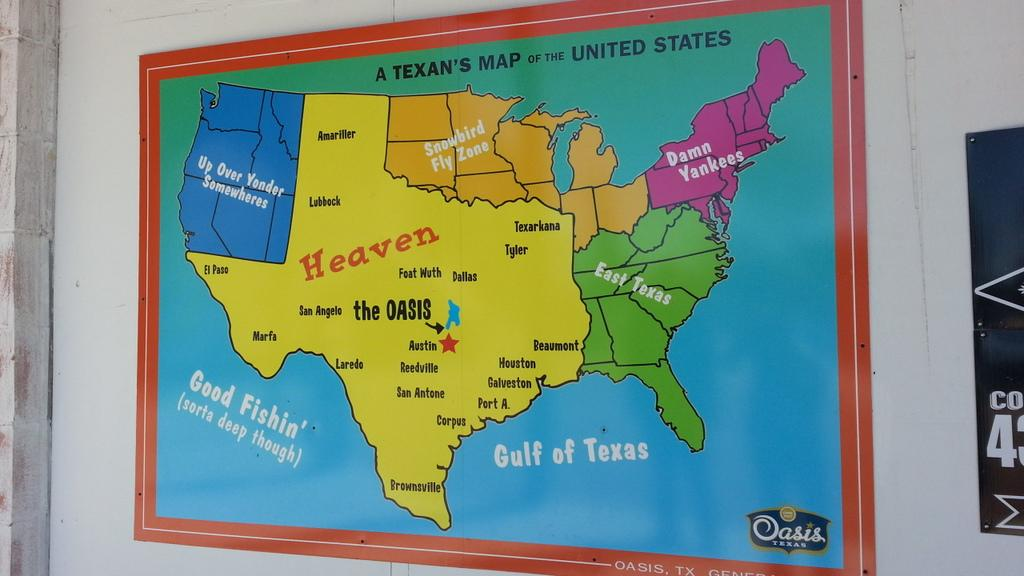<image>
Create a compact narrative representing the image presented. A large colored map of a Texan's Map of the United States. 